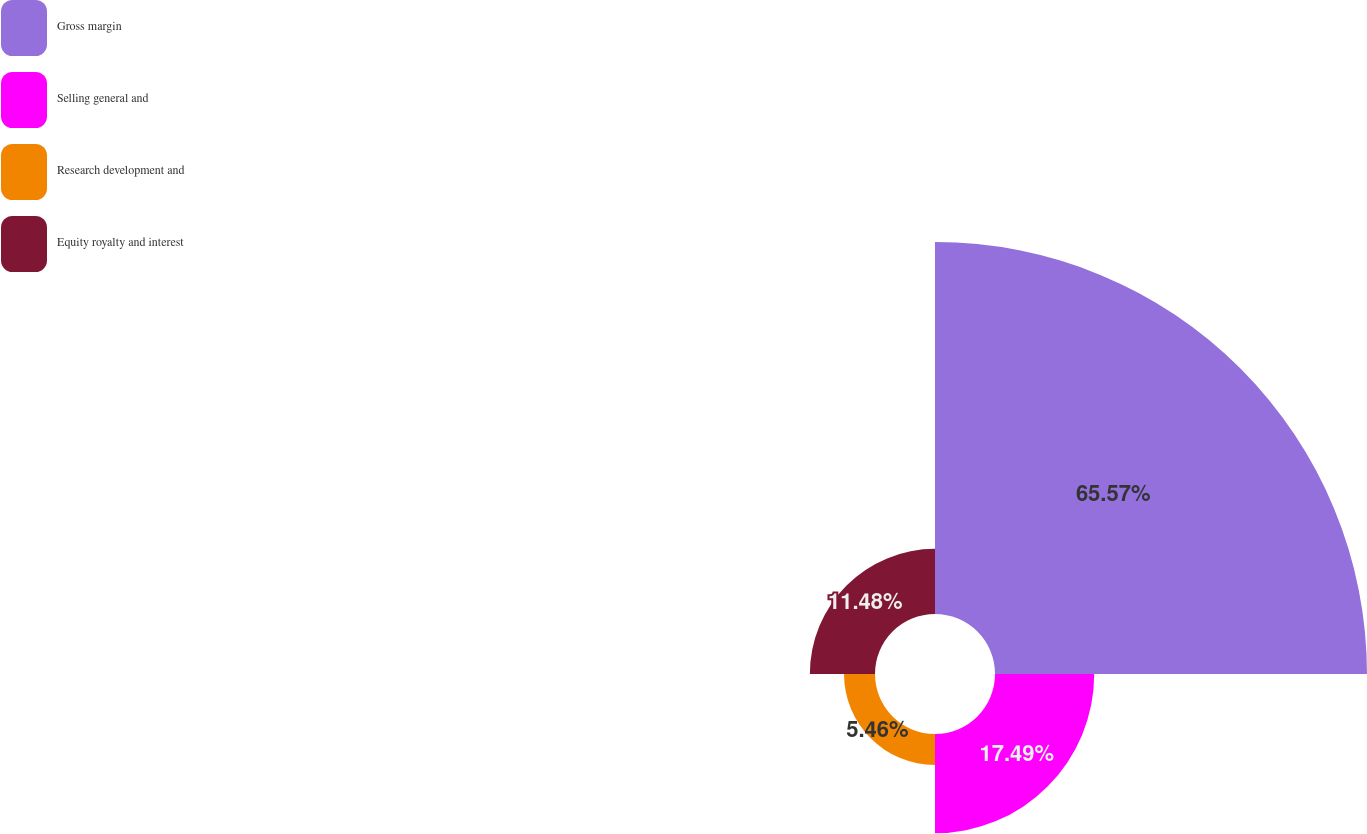Convert chart. <chart><loc_0><loc_0><loc_500><loc_500><pie_chart><fcel>Gross margin<fcel>Selling general and<fcel>Research development and<fcel>Equity royalty and interest<nl><fcel>65.57%<fcel>17.49%<fcel>5.46%<fcel>11.48%<nl></chart> 